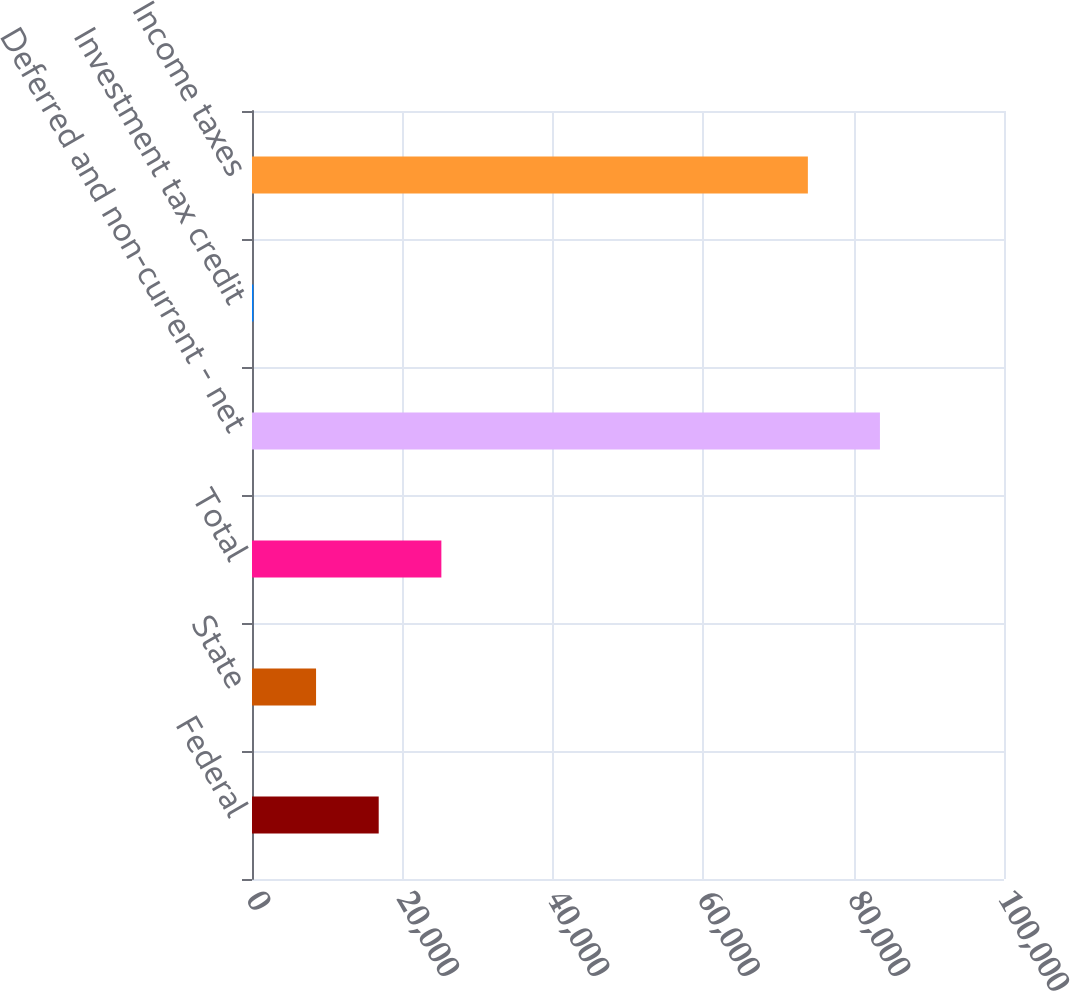<chart> <loc_0><loc_0><loc_500><loc_500><bar_chart><fcel>Federal<fcel>State<fcel>Total<fcel>Deferred and non-current - net<fcel>Investment tax credit<fcel>Income taxes<nl><fcel>16849.8<fcel>8518.4<fcel>25181.2<fcel>83501<fcel>187<fcel>73919<nl></chart> 